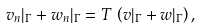Convert formula to latex. <formula><loc_0><loc_0><loc_500><loc_500>v _ { n } | _ { \Gamma } + w _ { n } | _ { \Gamma } = T \, \left ( v | _ { \Gamma } + w | _ { \Gamma } \right ) ,</formula> 